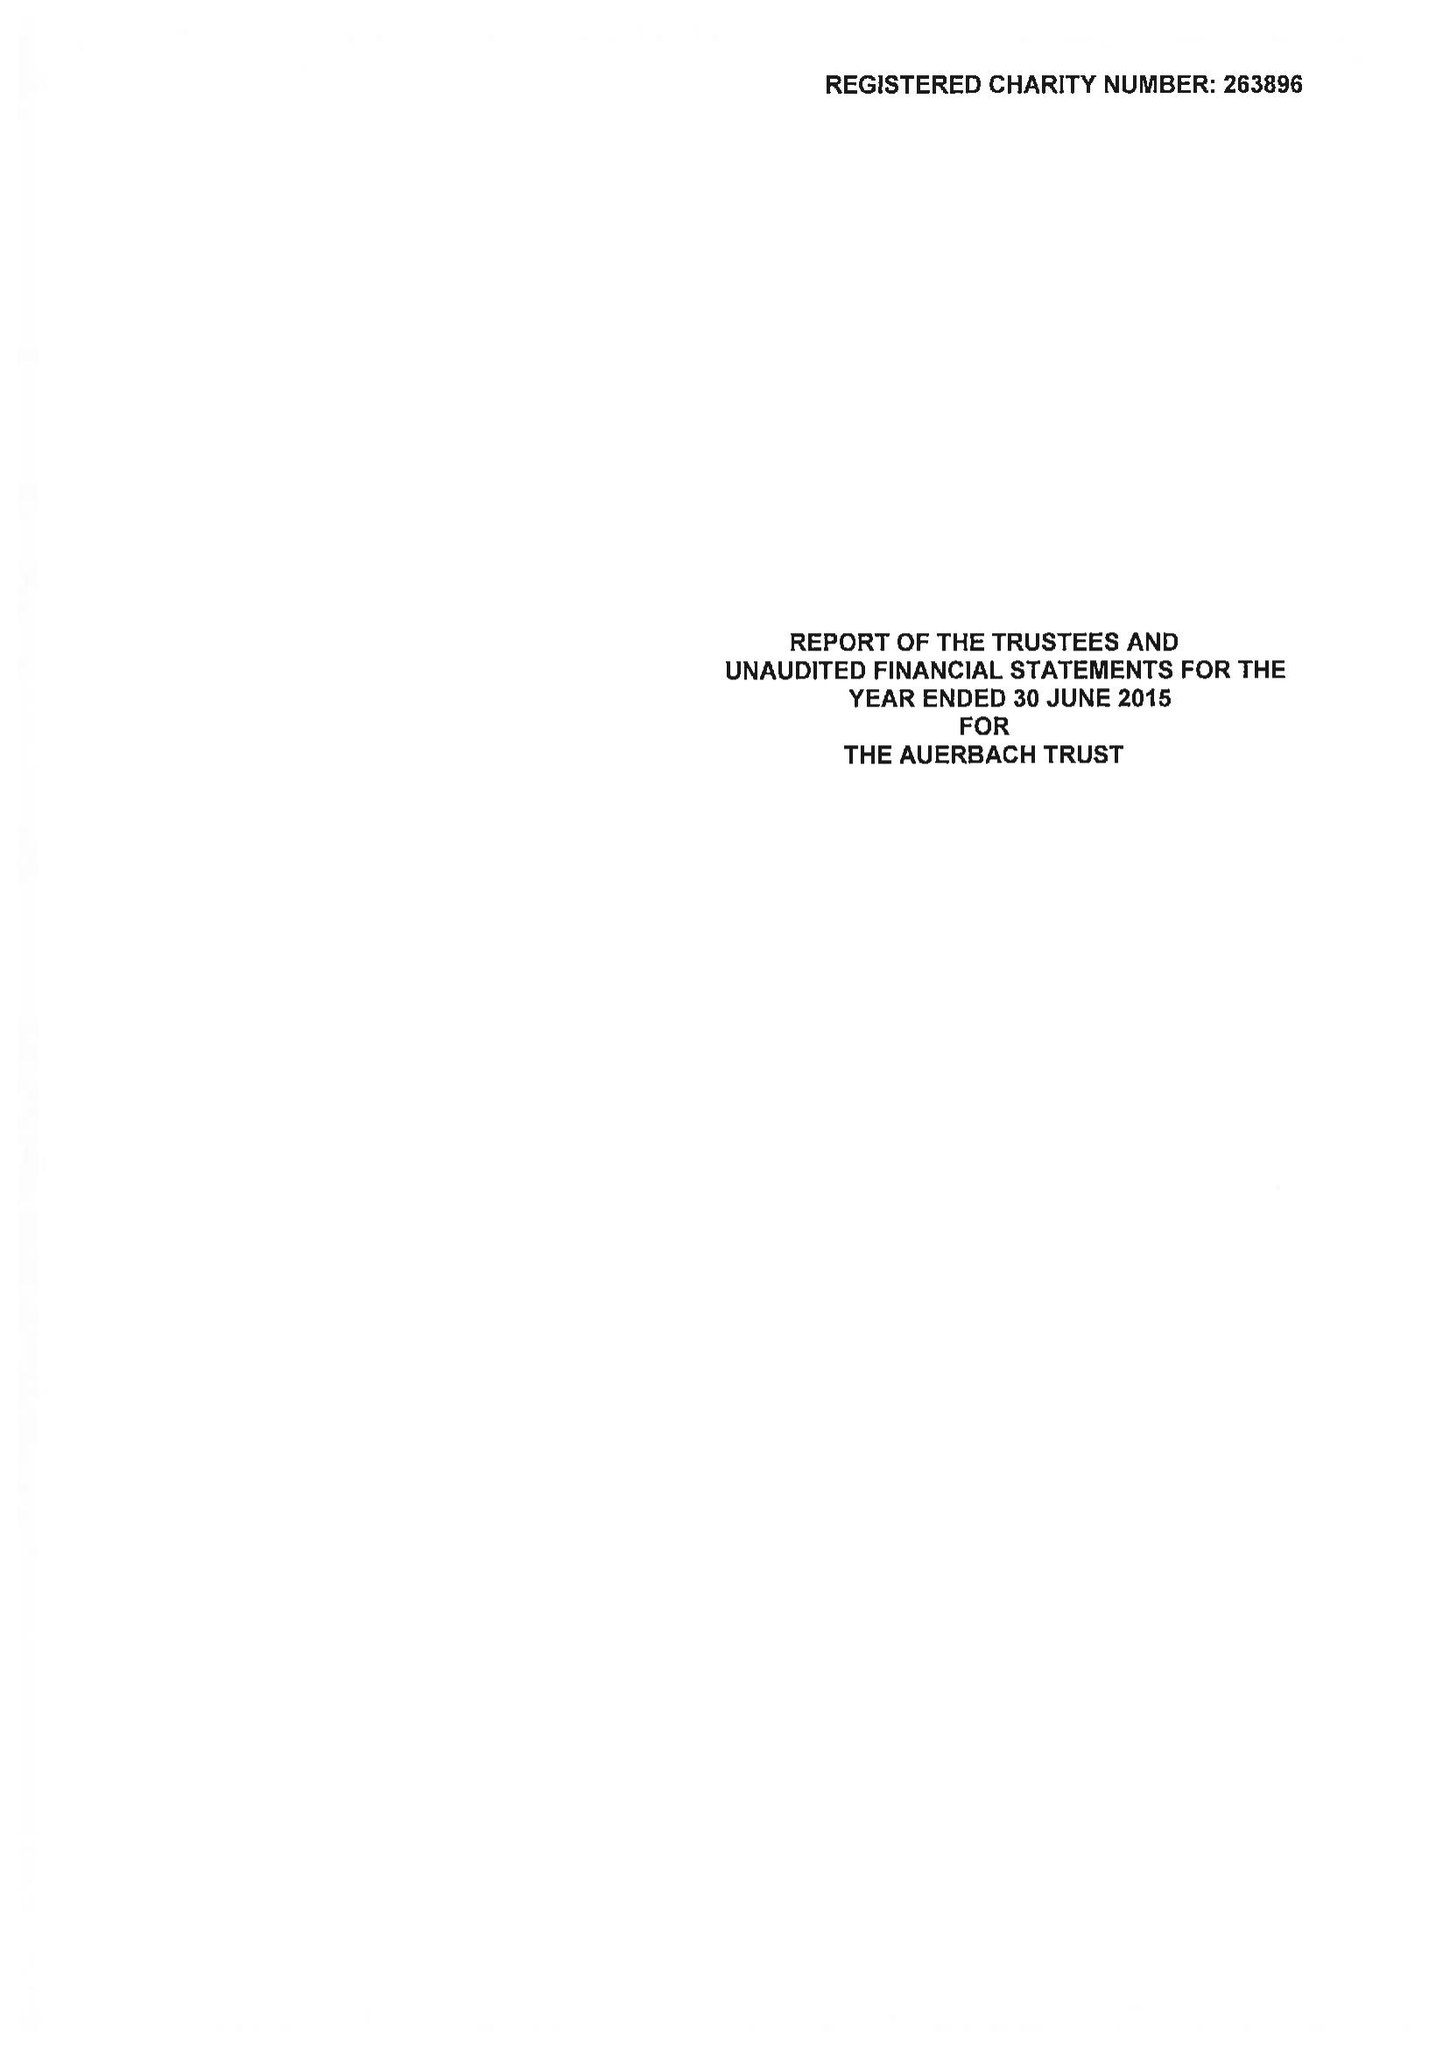What is the value for the spending_annually_in_british_pounds?
Answer the question using a single word or phrase. 44018.00 